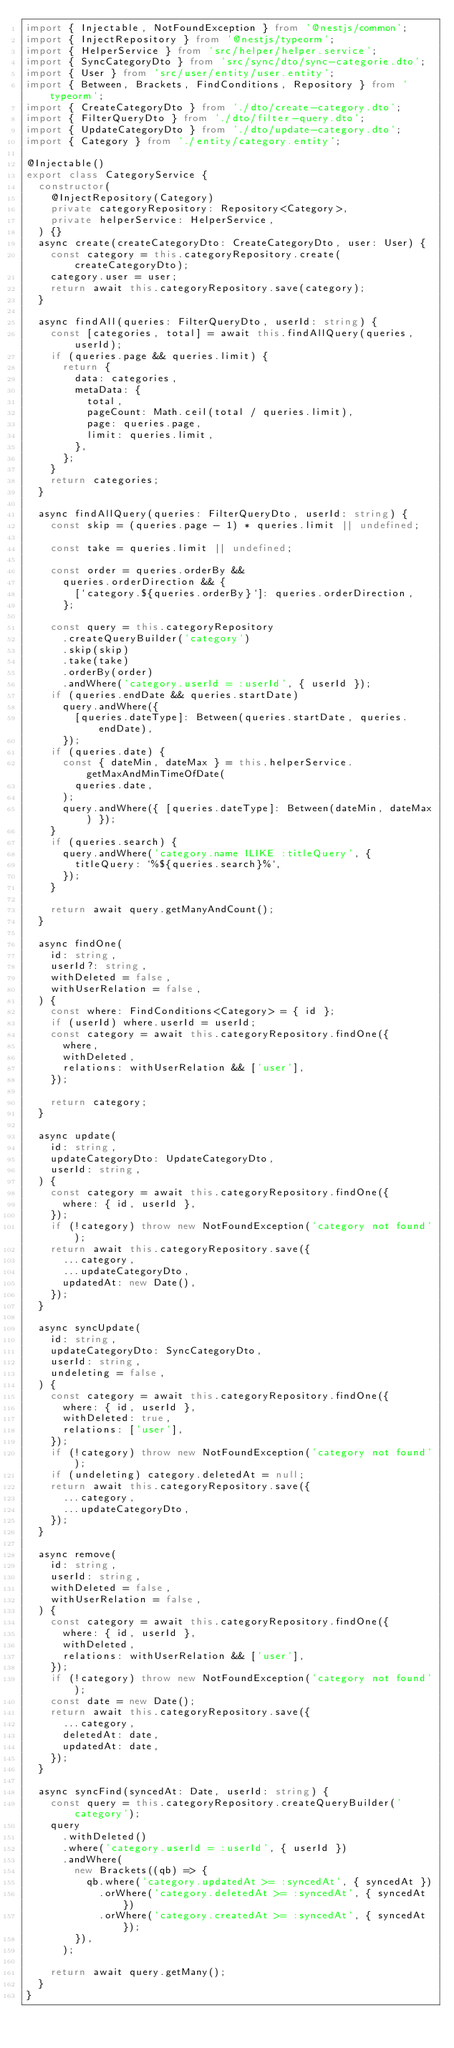<code> <loc_0><loc_0><loc_500><loc_500><_TypeScript_>import { Injectable, NotFoundException } from '@nestjs/common';
import { InjectRepository } from '@nestjs/typeorm';
import { HelperService } from 'src/helper/helper.service';
import { SyncCategoryDto } from 'src/sync/dto/sync-categorie.dto';
import { User } from 'src/user/entity/user.entity';
import { Between, Brackets, FindConditions, Repository } from 'typeorm';
import { CreateCategoryDto } from './dto/create-category.dto';
import { FilterQueryDto } from './dto/filter-query.dto';
import { UpdateCategoryDto } from './dto/update-category.dto';
import { Category } from './entity/category.entity';

@Injectable()
export class CategoryService {
  constructor(
    @InjectRepository(Category)
    private categoryRepository: Repository<Category>,
    private helperService: HelperService,
  ) {}
  async create(createCategoryDto: CreateCategoryDto, user: User) {
    const category = this.categoryRepository.create(createCategoryDto);
    category.user = user;
    return await this.categoryRepository.save(category);
  }

  async findAll(queries: FilterQueryDto, userId: string) {
    const [categories, total] = await this.findAllQuery(queries, userId);
    if (queries.page && queries.limit) {
      return {
        data: categories,
        metaData: {
          total,
          pageCount: Math.ceil(total / queries.limit),
          page: queries.page,
          limit: queries.limit,
        },
      };
    }
    return categories;
  }

  async findAllQuery(queries: FilterQueryDto, userId: string) {
    const skip = (queries.page - 1) * queries.limit || undefined;

    const take = queries.limit || undefined;

    const order = queries.orderBy &&
      queries.orderDirection && {
        [`category.${queries.orderBy}`]: queries.orderDirection,
      };

    const query = this.categoryRepository
      .createQueryBuilder('category')
      .skip(skip)
      .take(take)
      .orderBy(order)
      .andWhere('category.userId = :userId', { userId });
    if (queries.endDate && queries.startDate)
      query.andWhere({
        [queries.dateType]: Between(queries.startDate, queries.endDate),
      });
    if (queries.date) {
      const { dateMin, dateMax } = this.helperService.getMaxAndMinTimeOfDate(
        queries.date,
      );
      query.andWhere({ [queries.dateType]: Between(dateMin, dateMax) });
    }
    if (queries.search) {
      query.andWhere('category.name ILIKE :titleQuery', {
        titleQuery: `%${queries.search}%`,
      });
    }

    return await query.getManyAndCount();
  }

  async findOne(
    id: string,
    userId?: string,
    withDeleted = false,
    withUserRelation = false,
  ) {
    const where: FindConditions<Category> = { id };
    if (userId) where.userId = userId;
    const category = await this.categoryRepository.findOne({
      where,
      withDeleted,
      relations: withUserRelation && ['user'],
    });

    return category;
  }

  async update(
    id: string,
    updateCategoryDto: UpdateCategoryDto,
    userId: string,
  ) {
    const category = await this.categoryRepository.findOne({
      where: { id, userId },
    });
    if (!category) throw new NotFoundException('category not found');
    return await this.categoryRepository.save({
      ...category,
      ...updateCategoryDto,
      updatedAt: new Date(),
    });
  }

  async syncUpdate(
    id: string,
    updateCategoryDto: SyncCategoryDto,
    userId: string,
    undeleting = false,
  ) {
    const category = await this.categoryRepository.findOne({
      where: { id, userId },
      withDeleted: true,
      relations: ['user'],
    });
    if (!category) throw new NotFoundException('category not found');
    if (undeleting) category.deletedAt = null;
    return await this.categoryRepository.save({
      ...category,
      ...updateCategoryDto,
    });
  }

  async remove(
    id: string,
    userId: string,
    withDeleted = false,
    withUserRelation = false,
  ) {
    const category = await this.categoryRepository.findOne({
      where: { id, userId },
      withDeleted,
      relations: withUserRelation && ['user'],
    });
    if (!category) throw new NotFoundException('category not found');
    const date = new Date();
    return await this.categoryRepository.save({
      ...category,
      deletedAt: date,
      updatedAt: date,
    });
  }

  async syncFind(syncedAt: Date, userId: string) {
    const query = this.categoryRepository.createQueryBuilder('category');
    query
      .withDeleted()
      .where('category.userId = :userId', { userId })
      .andWhere(
        new Brackets((qb) => {
          qb.where('category.updatedAt >= :syncedAt', { syncedAt })
            .orWhere('category.deletedAt >= :syncedAt', { syncedAt })
            .orWhere('category.createdAt >= :syncedAt', { syncedAt });
        }),
      );

    return await query.getMany();
  }
}
</code> 